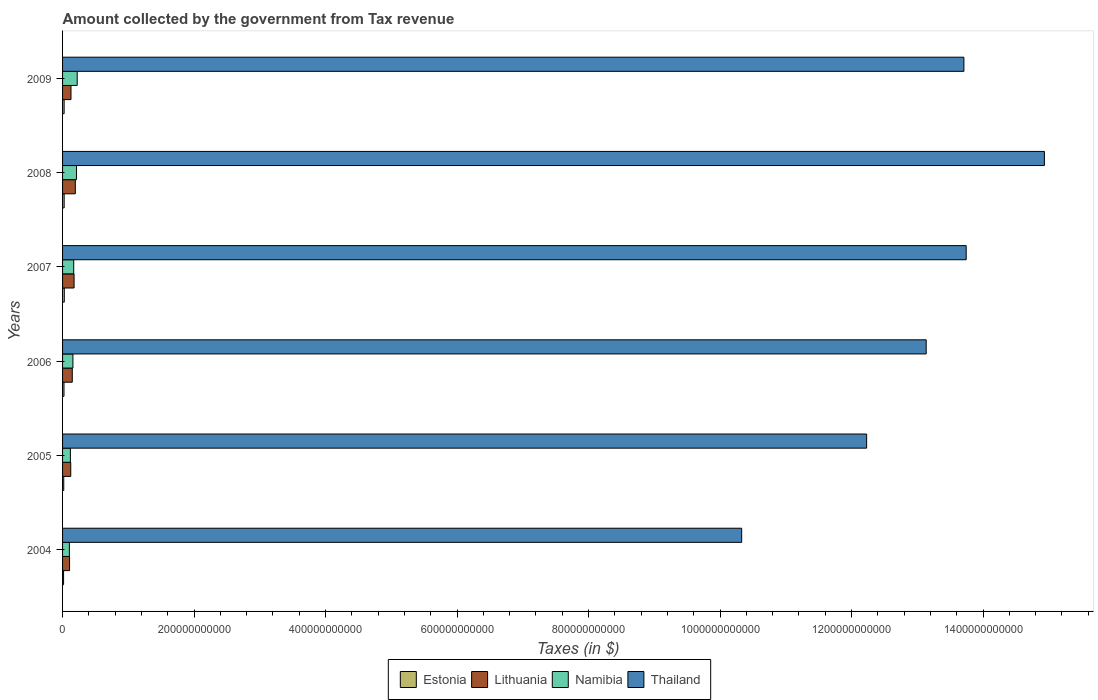How many groups of bars are there?
Offer a very short reply. 6. Are the number of bars per tick equal to the number of legend labels?
Offer a terse response. Yes. How many bars are there on the 5th tick from the top?
Make the answer very short. 4. How many bars are there on the 3rd tick from the bottom?
Provide a succinct answer. 4. What is the label of the 5th group of bars from the top?
Keep it short and to the point. 2005. In how many cases, is the number of bars for a given year not equal to the number of legend labels?
Keep it short and to the point. 0. What is the amount collected by the government from tax revenue in Estonia in 2007?
Ensure brevity in your answer.  2.63e+09. Across all years, what is the maximum amount collected by the government from tax revenue in Estonia?
Make the answer very short. 2.63e+09. Across all years, what is the minimum amount collected by the government from tax revenue in Thailand?
Ensure brevity in your answer.  1.03e+12. What is the total amount collected by the government from tax revenue in Estonia in the graph?
Ensure brevity in your answer.  1.30e+1. What is the difference between the amount collected by the government from tax revenue in Estonia in 2004 and that in 2008?
Offer a terse response. -8.84e+08. What is the difference between the amount collected by the government from tax revenue in Lithuania in 2008 and the amount collected by the government from tax revenue in Thailand in 2007?
Ensure brevity in your answer.  -1.36e+12. What is the average amount collected by the government from tax revenue in Thailand per year?
Your answer should be very brief. 1.30e+12. In the year 2004, what is the difference between the amount collected by the government from tax revenue in Thailand and amount collected by the government from tax revenue in Namibia?
Your response must be concise. 1.02e+12. What is the ratio of the amount collected by the government from tax revenue in Thailand in 2006 to that in 2008?
Provide a short and direct response. 0.88. What is the difference between the highest and the second highest amount collected by the government from tax revenue in Thailand?
Your answer should be very brief. 1.19e+11. What is the difference between the highest and the lowest amount collected by the government from tax revenue in Thailand?
Offer a terse response. 4.60e+11. Is the sum of the amount collected by the government from tax revenue in Lithuania in 2004 and 2008 greater than the maximum amount collected by the government from tax revenue in Thailand across all years?
Your answer should be compact. No. Is it the case that in every year, the sum of the amount collected by the government from tax revenue in Thailand and amount collected by the government from tax revenue in Lithuania is greater than the sum of amount collected by the government from tax revenue in Estonia and amount collected by the government from tax revenue in Namibia?
Offer a very short reply. Yes. What does the 3rd bar from the top in 2005 represents?
Offer a very short reply. Lithuania. What does the 4th bar from the bottom in 2007 represents?
Your answer should be very brief. Thailand. Is it the case that in every year, the sum of the amount collected by the government from tax revenue in Namibia and amount collected by the government from tax revenue in Lithuania is greater than the amount collected by the government from tax revenue in Estonia?
Provide a succinct answer. Yes. How many bars are there?
Make the answer very short. 24. Are all the bars in the graph horizontal?
Keep it short and to the point. Yes. How many years are there in the graph?
Your answer should be compact. 6. What is the difference between two consecutive major ticks on the X-axis?
Provide a short and direct response. 2.00e+11. Does the graph contain any zero values?
Keep it short and to the point. No. Does the graph contain grids?
Provide a succinct answer. No. How many legend labels are there?
Keep it short and to the point. 4. What is the title of the graph?
Ensure brevity in your answer.  Amount collected by the government from Tax revenue. Does "Kazakhstan" appear as one of the legend labels in the graph?
Your answer should be very brief. No. What is the label or title of the X-axis?
Make the answer very short. Taxes (in $). What is the label or title of the Y-axis?
Keep it short and to the point. Years. What is the Taxes (in $) of Estonia in 2004?
Make the answer very short. 1.55e+09. What is the Taxes (in $) of Lithuania in 2004?
Ensure brevity in your answer.  1.06e+1. What is the Taxes (in $) of Namibia in 2004?
Your answer should be very brief. 1.04e+1. What is the Taxes (in $) of Thailand in 2004?
Offer a terse response. 1.03e+12. What is the Taxes (in $) in Estonia in 2005?
Offer a terse response. 1.80e+09. What is the Taxes (in $) of Lithuania in 2005?
Keep it short and to the point. 1.24e+1. What is the Taxes (in $) of Namibia in 2005?
Provide a short and direct response. 1.19e+1. What is the Taxes (in $) of Thailand in 2005?
Your response must be concise. 1.22e+12. What is the Taxes (in $) of Estonia in 2006?
Provide a short and direct response. 2.17e+09. What is the Taxes (in $) of Lithuania in 2006?
Offer a terse response. 1.48e+1. What is the Taxes (in $) of Namibia in 2006?
Make the answer very short. 1.57e+1. What is the Taxes (in $) in Thailand in 2006?
Provide a short and direct response. 1.31e+12. What is the Taxes (in $) of Estonia in 2007?
Give a very brief answer. 2.63e+09. What is the Taxes (in $) in Lithuania in 2007?
Make the answer very short. 1.75e+1. What is the Taxes (in $) of Namibia in 2007?
Your answer should be very brief. 1.70e+1. What is the Taxes (in $) of Thailand in 2007?
Offer a terse response. 1.37e+12. What is the Taxes (in $) of Estonia in 2008?
Ensure brevity in your answer.  2.43e+09. What is the Taxes (in $) in Lithuania in 2008?
Offer a very short reply. 1.94e+1. What is the Taxes (in $) of Namibia in 2008?
Keep it short and to the point. 2.12e+1. What is the Taxes (in $) of Thailand in 2008?
Provide a succinct answer. 1.49e+12. What is the Taxes (in $) in Estonia in 2009?
Your answer should be compact. 2.38e+09. What is the Taxes (in $) of Lithuania in 2009?
Keep it short and to the point. 1.28e+1. What is the Taxes (in $) of Namibia in 2009?
Provide a succinct answer. 2.23e+1. What is the Taxes (in $) of Thailand in 2009?
Your answer should be compact. 1.37e+12. Across all years, what is the maximum Taxes (in $) of Estonia?
Give a very brief answer. 2.63e+09. Across all years, what is the maximum Taxes (in $) in Lithuania?
Give a very brief answer. 1.94e+1. Across all years, what is the maximum Taxes (in $) in Namibia?
Offer a terse response. 2.23e+1. Across all years, what is the maximum Taxes (in $) in Thailand?
Make the answer very short. 1.49e+12. Across all years, what is the minimum Taxes (in $) of Estonia?
Your answer should be compact. 1.55e+09. Across all years, what is the minimum Taxes (in $) of Lithuania?
Give a very brief answer. 1.06e+1. Across all years, what is the minimum Taxes (in $) in Namibia?
Provide a short and direct response. 1.04e+1. Across all years, what is the minimum Taxes (in $) of Thailand?
Your response must be concise. 1.03e+12. What is the total Taxes (in $) of Estonia in the graph?
Give a very brief answer. 1.30e+1. What is the total Taxes (in $) of Lithuania in the graph?
Keep it short and to the point. 8.75e+1. What is the total Taxes (in $) of Namibia in the graph?
Offer a terse response. 9.85e+1. What is the total Taxes (in $) in Thailand in the graph?
Your response must be concise. 7.81e+12. What is the difference between the Taxes (in $) in Estonia in 2004 and that in 2005?
Offer a very short reply. -2.50e+08. What is the difference between the Taxes (in $) in Lithuania in 2004 and that in 2005?
Keep it short and to the point. -1.80e+09. What is the difference between the Taxes (in $) in Namibia in 2004 and that in 2005?
Your answer should be very brief. -1.53e+09. What is the difference between the Taxes (in $) in Thailand in 2004 and that in 2005?
Offer a terse response. -1.90e+11. What is the difference between the Taxes (in $) in Estonia in 2004 and that in 2006?
Offer a terse response. -6.21e+08. What is the difference between the Taxes (in $) of Lithuania in 2004 and that in 2006?
Make the answer very short. -4.15e+09. What is the difference between the Taxes (in $) in Namibia in 2004 and that in 2006?
Provide a succinct answer. -5.38e+09. What is the difference between the Taxes (in $) of Thailand in 2004 and that in 2006?
Make the answer very short. -2.81e+11. What is the difference between the Taxes (in $) of Estonia in 2004 and that in 2007?
Offer a very short reply. -1.09e+09. What is the difference between the Taxes (in $) in Lithuania in 2004 and that in 2007?
Make the answer very short. -6.88e+09. What is the difference between the Taxes (in $) in Namibia in 2004 and that in 2007?
Keep it short and to the point. -6.60e+09. What is the difference between the Taxes (in $) of Thailand in 2004 and that in 2007?
Your answer should be very brief. -3.41e+11. What is the difference between the Taxes (in $) of Estonia in 2004 and that in 2008?
Your response must be concise. -8.84e+08. What is the difference between the Taxes (in $) in Lithuania in 2004 and that in 2008?
Provide a succinct answer. -8.75e+09. What is the difference between the Taxes (in $) in Namibia in 2004 and that in 2008?
Give a very brief answer. -1.09e+1. What is the difference between the Taxes (in $) of Thailand in 2004 and that in 2008?
Ensure brevity in your answer.  -4.60e+11. What is the difference between the Taxes (in $) in Estonia in 2004 and that in 2009?
Ensure brevity in your answer.  -8.34e+08. What is the difference between the Taxes (in $) in Lithuania in 2004 and that in 2009?
Provide a short and direct response. -2.16e+09. What is the difference between the Taxes (in $) of Namibia in 2004 and that in 2009?
Keep it short and to the point. -1.19e+1. What is the difference between the Taxes (in $) in Thailand in 2004 and that in 2009?
Provide a succinct answer. -3.38e+11. What is the difference between the Taxes (in $) in Estonia in 2005 and that in 2006?
Keep it short and to the point. -3.71e+08. What is the difference between the Taxes (in $) of Lithuania in 2005 and that in 2006?
Keep it short and to the point. -2.35e+09. What is the difference between the Taxes (in $) in Namibia in 2005 and that in 2006?
Provide a short and direct response. -3.85e+09. What is the difference between the Taxes (in $) of Thailand in 2005 and that in 2006?
Make the answer very short. -9.06e+1. What is the difference between the Taxes (in $) of Estonia in 2005 and that in 2007?
Provide a short and direct response. -8.36e+08. What is the difference between the Taxes (in $) in Lithuania in 2005 and that in 2007?
Provide a short and direct response. -5.07e+09. What is the difference between the Taxes (in $) of Namibia in 2005 and that in 2007?
Provide a short and direct response. -5.07e+09. What is the difference between the Taxes (in $) of Thailand in 2005 and that in 2007?
Keep it short and to the point. -1.51e+11. What is the difference between the Taxes (in $) of Estonia in 2005 and that in 2008?
Ensure brevity in your answer.  -6.34e+08. What is the difference between the Taxes (in $) in Lithuania in 2005 and that in 2008?
Offer a terse response. -6.94e+09. What is the difference between the Taxes (in $) in Namibia in 2005 and that in 2008?
Offer a terse response. -9.33e+09. What is the difference between the Taxes (in $) of Thailand in 2005 and that in 2008?
Ensure brevity in your answer.  -2.70e+11. What is the difference between the Taxes (in $) of Estonia in 2005 and that in 2009?
Provide a short and direct response. -5.85e+08. What is the difference between the Taxes (in $) in Lithuania in 2005 and that in 2009?
Provide a short and direct response. -3.57e+08. What is the difference between the Taxes (in $) in Namibia in 2005 and that in 2009?
Offer a terse response. -1.04e+1. What is the difference between the Taxes (in $) of Thailand in 2005 and that in 2009?
Offer a terse response. -1.48e+11. What is the difference between the Taxes (in $) of Estonia in 2006 and that in 2007?
Your answer should be very brief. -4.65e+08. What is the difference between the Taxes (in $) in Lithuania in 2006 and that in 2007?
Keep it short and to the point. -2.73e+09. What is the difference between the Taxes (in $) in Namibia in 2006 and that in 2007?
Your answer should be compact. -1.22e+09. What is the difference between the Taxes (in $) of Thailand in 2006 and that in 2007?
Provide a succinct answer. -6.08e+1. What is the difference between the Taxes (in $) in Estonia in 2006 and that in 2008?
Provide a succinct answer. -2.63e+08. What is the difference between the Taxes (in $) in Lithuania in 2006 and that in 2008?
Offer a very short reply. -4.60e+09. What is the difference between the Taxes (in $) of Namibia in 2006 and that in 2008?
Provide a short and direct response. -5.48e+09. What is the difference between the Taxes (in $) in Thailand in 2006 and that in 2008?
Give a very brief answer. -1.80e+11. What is the difference between the Taxes (in $) of Estonia in 2006 and that in 2009?
Make the answer very short. -2.13e+08. What is the difference between the Taxes (in $) of Lithuania in 2006 and that in 2009?
Offer a very short reply. 1.99e+09. What is the difference between the Taxes (in $) in Namibia in 2006 and that in 2009?
Ensure brevity in your answer.  -6.53e+09. What is the difference between the Taxes (in $) in Thailand in 2006 and that in 2009?
Keep it short and to the point. -5.74e+1. What is the difference between the Taxes (in $) of Estonia in 2007 and that in 2008?
Give a very brief answer. 2.02e+08. What is the difference between the Taxes (in $) in Lithuania in 2007 and that in 2008?
Keep it short and to the point. -1.87e+09. What is the difference between the Taxes (in $) of Namibia in 2007 and that in 2008?
Provide a short and direct response. -4.25e+09. What is the difference between the Taxes (in $) in Thailand in 2007 and that in 2008?
Make the answer very short. -1.19e+11. What is the difference between the Taxes (in $) in Estonia in 2007 and that in 2009?
Offer a very short reply. 2.51e+08. What is the difference between the Taxes (in $) of Lithuania in 2007 and that in 2009?
Offer a very short reply. 4.72e+09. What is the difference between the Taxes (in $) in Namibia in 2007 and that in 2009?
Give a very brief answer. -5.30e+09. What is the difference between the Taxes (in $) in Thailand in 2007 and that in 2009?
Keep it short and to the point. 3.46e+09. What is the difference between the Taxes (in $) in Estonia in 2008 and that in 2009?
Keep it short and to the point. 4.95e+07. What is the difference between the Taxes (in $) in Lithuania in 2008 and that in 2009?
Your answer should be very brief. 6.59e+09. What is the difference between the Taxes (in $) in Namibia in 2008 and that in 2009?
Ensure brevity in your answer.  -1.05e+09. What is the difference between the Taxes (in $) of Thailand in 2008 and that in 2009?
Offer a terse response. 1.22e+11. What is the difference between the Taxes (in $) in Estonia in 2004 and the Taxes (in $) in Lithuania in 2005?
Your answer should be very brief. -1.09e+1. What is the difference between the Taxes (in $) in Estonia in 2004 and the Taxes (in $) in Namibia in 2005?
Your answer should be very brief. -1.03e+1. What is the difference between the Taxes (in $) in Estonia in 2004 and the Taxes (in $) in Thailand in 2005?
Your answer should be compact. -1.22e+12. What is the difference between the Taxes (in $) of Lithuania in 2004 and the Taxes (in $) of Namibia in 2005?
Offer a terse response. -1.26e+09. What is the difference between the Taxes (in $) of Lithuania in 2004 and the Taxes (in $) of Thailand in 2005?
Give a very brief answer. -1.21e+12. What is the difference between the Taxes (in $) in Namibia in 2004 and the Taxes (in $) in Thailand in 2005?
Your answer should be compact. -1.21e+12. What is the difference between the Taxes (in $) of Estonia in 2004 and the Taxes (in $) of Lithuania in 2006?
Ensure brevity in your answer.  -1.32e+1. What is the difference between the Taxes (in $) of Estonia in 2004 and the Taxes (in $) of Namibia in 2006?
Your answer should be very brief. -1.42e+1. What is the difference between the Taxes (in $) in Estonia in 2004 and the Taxes (in $) in Thailand in 2006?
Keep it short and to the point. -1.31e+12. What is the difference between the Taxes (in $) of Lithuania in 2004 and the Taxes (in $) of Namibia in 2006?
Provide a short and direct response. -5.11e+09. What is the difference between the Taxes (in $) of Lithuania in 2004 and the Taxes (in $) of Thailand in 2006?
Make the answer very short. -1.30e+12. What is the difference between the Taxes (in $) in Namibia in 2004 and the Taxes (in $) in Thailand in 2006?
Make the answer very short. -1.30e+12. What is the difference between the Taxes (in $) of Estonia in 2004 and the Taxes (in $) of Lithuania in 2007?
Offer a terse response. -1.60e+1. What is the difference between the Taxes (in $) in Estonia in 2004 and the Taxes (in $) in Namibia in 2007?
Ensure brevity in your answer.  -1.54e+1. What is the difference between the Taxes (in $) of Estonia in 2004 and the Taxes (in $) of Thailand in 2007?
Offer a terse response. -1.37e+12. What is the difference between the Taxes (in $) in Lithuania in 2004 and the Taxes (in $) in Namibia in 2007?
Your answer should be compact. -6.33e+09. What is the difference between the Taxes (in $) of Lithuania in 2004 and the Taxes (in $) of Thailand in 2007?
Make the answer very short. -1.36e+12. What is the difference between the Taxes (in $) of Namibia in 2004 and the Taxes (in $) of Thailand in 2007?
Your answer should be very brief. -1.36e+12. What is the difference between the Taxes (in $) of Estonia in 2004 and the Taxes (in $) of Lithuania in 2008?
Offer a very short reply. -1.78e+1. What is the difference between the Taxes (in $) in Estonia in 2004 and the Taxes (in $) in Namibia in 2008?
Ensure brevity in your answer.  -1.97e+1. What is the difference between the Taxes (in $) in Estonia in 2004 and the Taxes (in $) in Thailand in 2008?
Your response must be concise. -1.49e+12. What is the difference between the Taxes (in $) in Lithuania in 2004 and the Taxes (in $) in Namibia in 2008?
Give a very brief answer. -1.06e+1. What is the difference between the Taxes (in $) in Lithuania in 2004 and the Taxes (in $) in Thailand in 2008?
Offer a terse response. -1.48e+12. What is the difference between the Taxes (in $) in Namibia in 2004 and the Taxes (in $) in Thailand in 2008?
Keep it short and to the point. -1.48e+12. What is the difference between the Taxes (in $) in Estonia in 2004 and the Taxes (in $) in Lithuania in 2009?
Keep it short and to the point. -1.12e+1. What is the difference between the Taxes (in $) in Estonia in 2004 and the Taxes (in $) in Namibia in 2009?
Offer a very short reply. -2.07e+1. What is the difference between the Taxes (in $) of Estonia in 2004 and the Taxes (in $) of Thailand in 2009?
Ensure brevity in your answer.  -1.37e+12. What is the difference between the Taxes (in $) of Lithuania in 2004 and the Taxes (in $) of Namibia in 2009?
Offer a terse response. -1.16e+1. What is the difference between the Taxes (in $) in Lithuania in 2004 and the Taxes (in $) in Thailand in 2009?
Your answer should be very brief. -1.36e+12. What is the difference between the Taxes (in $) of Namibia in 2004 and the Taxes (in $) of Thailand in 2009?
Offer a terse response. -1.36e+12. What is the difference between the Taxes (in $) of Estonia in 2005 and the Taxes (in $) of Lithuania in 2006?
Keep it short and to the point. -1.30e+1. What is the difference between the Taxes (in $) of Estonia in 2005 and the Taxes (in $) of Namibia in 2006?
Offer a very short reply. -1.40e+1. What is the difference between the Taxes (in $) of Estonia in 2005 and the Taxes (in $) of Thailand in 2006?
Your response must be concise. -1.31e+12. What is the difference between the Taxes (in $) in Lithuania in 2005 and the Taxes (in $) in Namibia in 2006?
Your answer should be very brief. -3.31e+09. What is the difference between the Taxes (in $) of Lithuania in 2005 and the Taxes (in $) of Thailand in 2006?
Your answer should be very brief. -1.30e+12. What is the difference between the Taxes (in $) in Namibia in 2005 and the Taxes (in $) in Thailand in 2006?
Make the answer very short. -1.30e+12. What is the difference between the Taxes (in $) in Estonia in 2005 and the Taxes (in $) in Lithuania in 2007?
Make the answer very short. -1.57e+1. What is the difference between the Taxes (in $) in Estonia in 2005 and the Taxes (in $) in Namibia in 2007?
Your answer should be compact. -1.52e+1. What is the difference between the Taxes (in $) of Estonia in 2005 and the Taxes (in $) of Thailand in 2007?
Your answer should be very brief. -1.37e+12. What is the difference between the Taxes (in $) of Lithuania in 2005 and the Taxes (in $) of Namibia in 2007?
Your answer should be very brief. -4.53e+09. What is the difference between the Taxes (in $) in Lithuania in 2005 and the Taxes (in $) in Thailand in 2007?
Your response must be concise. -1.36e+12. What is the difference between the Taxes (in $) of Namibia in 2005 and the Taxes (in $) of Thailand in 2007?
Your answer should be very brief. -1.36e+12. What is the difference between the Taxes (in $) of Estonia in 2005 and the Taxes (in $) of Lithuania in 2008?
Your answer should be very brief. -1.76e+1. What is the difference between the Taxes (in $) in Estonia in 2005 and the Taxes (in $) in Namibia in 2008?
Your answer should be very brief. -1.94e+1. What is the difference between the Taxes (in $) of Estonia in 2005 and the Taxes (in $) of Thailand in 2008?
Keep it short and to the point. -1.49e+12. What is the difference between the Taxes (in $) of Lithuania in 2005 and the Taxes (in $) of Namibia in 2008?
Your answer should be compact. -8.79e+09. What is the difference between the Taxes (in $) in Lithuania in 2005 and the Taxes (in $) in Thailand in 2008?
Provide a succinct answer. -1.48e+12. What is the difference between the Taxes (in $) in Namibia in 2005 and the Taxes (in $) in Thailand in 2008?
Your response must be concise. -1.48e+12. What is the difference between the Taxes (in $) of Estonia in 2005 and the Taxes (in $) of Lithuania in 2009?
Keep it short and to the point. -1.10e+1. What is the difference between the Taxes (in $) in Estonia in 2005 and the Taxes (in $) in Namibia in 2009?
Your answer should be very brief. -2.05e+1. What is the difference between the Taxes (in $) in Estonia in 2005 and the Taxes (in $) in Thailand in 2009?
Your answer should be very brief. -1.37e+12. What is the difference between the Taxes (in $) of Lithuania in 2005 and the Taxes (in $) of Namibia in 2009?
Ensure brevity in your answer.  -9.84e+09. What is the difference between the Taxes (in $) in Lithuania in 2005 and the Taxes (in $) in Thailand in 2009?
Your response must be concise. -1.36e+12. What is the difference between the Taxes (in $) in Namibia in 2005 and the Taxes (in $) in Thailand in 2009?
Offer a terse response. -1.36e+12. What is the difference between the Taxes (in $) of Estonia in 2006 and the Taxes (in $) of Lithuania in 2007?
Make the answer very short. -1.53e+1. What is the difference between the Taxes (in $) of Estonia in 2006 and the Taxes (in $) of Namibia in 2007?
Offer a terse response. -1.48e+1. What is the difference between the Taxes (in $) of Estonia in 2006 and the Taxes (in $) of Thailand in 2007?
Offer a terse response. -1.37e+12. What is the difference between the Taxes (in $) in Lithuania in 2006 and the Taxes (in $) in Namibia in 2007?
Provide a short and direct response. -2.18e+09. What is the difference between the Taxes (in $) in Lithuania in 2006 and the Taxes (in $) in Thailand in 2007?
Offer a very short reply. -1.36e+12. What is the difference between the Taxes (in $) in Namibia in 2006 and the Taxes (in $) in Thailand in 2007?
Your answer should be compact. -1.36e+12. What is the difference between the Taxes (in $) of Estonia in 2006 and the Taxes (in $) of Lithuania in 2008?
Offer a very short reply. -1.72e+1. What is the difference between the Taxes (in $) of Estonia in 2006 and the Taxes (in $) of Namibia in 2008?
Ensure brevity in your answer.  -1.91e+1. What is the difference between the Taxes (in $) of Estonia in 2006 and the Taxes (in $) of Thailand in 2008?
Keep it short and to the point. -1.49e+12. What is the difference between the Taxes (in $) of Lithuania in 2006 and the Taxes (in $) of Namibia in 2008?
Make the answer very short. -6.44e+09. What is the difference between the Taxes (in $) in Lithuania in 2006 and the Taxes (in $) in Thailand in 2008?
Keep it short and to the point. -1.48e+12. What is the difference between the Taxes (in $) of Namibia in 2006 and the Taxes (in $) of Thailand in 2008?
Provide a short and direct response. -1.48e+12. What is the difference between the Taxes (in $) in Estonia in 2006 and the Taxes (in $) in Lithuania in 2009?
Provide a succinct answer. -1.06e+1. What is the difference between the Taxes (in $) in Estonia in 2006 and the Taxes (in $) in Namibia in 2009?
Offer a very short reply. -2.01e+1. What is the difference between the Taxes (in $) in Estonia in 2006 and the Taxes (in $) in Thailand in 2009?
Give a very brief answer. -1.37e+12. What is the difference between the Taxes (in $) of Lithuania in 2006 and the Taxes (in $) of Namibia in 2009?
Your answer should be very brief. -7.49e+09. What is the difference between the Taxes (in $) in Lithuania in 2006 and the Taxes (in $) in Thailand in 2009?
Ensure brevity in your answer.  -1.36e+12. What is the difference between the Taxes (in $) of Namibia in 2006 and the Taxes (in $) of Thailand in 2009?
Provide a succinct answer. -1.36e+12. What is the difference between the Taxes (in $) of Estonia in 2007 and the Taxes (in $) of Lithuania in 2008?
Offer a terse response. -1.67e+1. What is the difference between the Taxes (in $) in Estonia in 2007 and the Taxes (in $) in Namibia in 2008?
Make the answer very short. -1.86e+1. What is the difference between the Taxes (in $) of Estonia in 2007 and the Taxes (in $) of Thailand in 2008?
Provide a succinct answer. -1.49e+12. What is the difference between the Taxes (in $) of Lithuania in 2007 and the Taxes (in $) of Namibia in 2008?
Keep it short and to the point. -3.71e+09. What is the difference between the Taxes (in $) in Lithuania in 2007 and the Taxes (in $) in Thailand in 2008?
Ensure brevity in your answer.  -1.48e+12. What is the difference between the Taxes (in $) of Namibia in 2007 and the Taxes (in $) of Thailand in 2008?
Offer a very short reply. -1.48e+12. What is the difference between the Taxes (in $) in Estonia in 2007 and the Taxes (in $) in Lithuania in 2009?
Provide a succinct answer. -1.02e+1. What is the difference between the Taxes (in $) in Estonia in 2007 and the Taxes (in $) in Namibia in 2009?
Provide a succinct answer. -1.96e+1. What is the difference between the Taxes (in $) of Estonia in 2007 and the Taxes (in $) of Thailand in 2009?
Keep it short and to the point. -1.37e+12. What is the difference between the Taxes (in $) of Lithuania in 2007 and the Taxes (in $) of Namibia in 2009?
Ensure brevity in your answer.  -4.76e+09. What is the difference between the Taxes (in $) in Lithuania in 2007 and the Taxes (in $) in Thailand in 2009?
Provide a short and direct response. -1.35e+12. What is the difference between the Taxes (in $) in Namibia in 2007 and the Taxes (in $) in Thailand in 2009?
Offer a very short reply. -1.35e+12. What is the difference between the Taxes (in $) of Estonia in 2008 and the Taxes (in $) of Lithuania in 2009?
Provide a succinct answer. -1.04e+1. What is the difference between the Taxes (in $) of Estonia in 2008 and the Taxes (in $) of Namibia in 2009?
Your answer should be very brief. -1.98e+1. What is the difference between the Taxes (in $) of Estonia in 2008 and the Taxes (in $) of Thailand in 2009?
Make the answer very short. -1.37e+12. What is the difference between the Taxes (in $) of Lithuania in 2008 and the Taxes (in $) of Namibia in 2009?
Make the answer very short. -2.89e+09. What is the difference between the Taxes (in $) of Lithuania in 2008 and the Taxes (in $) of Thailand in 2009?
Offer a very short reply. -1.35e+12. What is the difference between the Taxes (in $) of Namibia in 2008 and the Taxes (in $) of Thailand in 2009?
Offer a terse response. -1.35e+12. What is the average Taxes (in $) of Estonia per year?
Your answer should be very brief. 2.16e+09. What is the average Taxes (in $) of Lithuania per year?
Make the answer very short. 1.46e+1. What is the average Taxes (in $) in Namibia per year?
Provide a succinct answer. 1.64e+1. What is the average Taxes (in $) of Thailand per year?
Make the answer very short. 1.30e+12. In the year 2004, what is the difference between the Taxes (in $) of Estonia and Taxes (in $) of Lithuania?
Your answer should be very brief. -9.09e+09. In the year 2004, what is the difference between the Taxes (in $) in Estonia and Taxes (in $) in Namibia?
Offer a very short reply. -8.82e+09. In the year 2004, what is the difference between the Taxes (in $) in Estonia and Taxes (in $) in Thailand?
Give a very brief answer. -1.03e+12. In the year 2004, what is the difference between the Taxes (in $) in Lithuania and Taxes (in $) in Namibia?
Keep it short and to the point. 2.69e+08. In the year 2004, what is the difference between the Taxes (in $) of Lithuania and Taxes (in $) of Thailand?
Keep it short and to the point. -1.02e+12. In the year 2004, what is the difference between the Taxes (in $) of Namibia and Taxes (in $) of Thailand?
Provide a short and direct response. -1.02e+12. In the year 2005, what is the difference between the Taxes (in $) of Estonia and Taxes (in $) of Lithuania?
Your response must be concise. -1.06e+1. In the year 2005, what is the difference between the Taxes (in $) in Estonia and Taxes (in $) in Namibia?
Your response must be concise. -1.01e+1. In the year 2005, what is the difference between the Taxes (in $) in Estonia and Taxes (in $) in Thailand?
Your answer should be compact. -1.22e+12. In the year 2005, what is the difference between the Taxes (in $) in Lithuania and Taxes (in $) in Namibia?
Your answer should be compact. 5.42e+08. In the year 2005, what is the difference between the Taxes (in $) of Lithuania and Taxes (in $) of Thailand?
Ensure brevity in your answer.  -1.21e+12. In the year 2005, what is the difference between the Taxes (in $) in Namibia and Taxes (in $) in Thailand?
Offer a very short reply. -1.21e+12. In the year 2006, what is the difference between the Taxes (in $) of Estonia and Taxes (in $) of Lithuania?
Offer a very short reply. -1.26e+1. In the year 2006, what is the difference between the Taxes (in $) of Estonia and Taxes (in $) of Namibia?
Make the answer very short. -1.36e+1. In the year 2006, what is the difference between the Taxes (in $) of Estonia and Taxes (in $) of Thailand?
Offer a very short reply. -1.31e+12. In the year 2006, what is the difference between the Taxes (in $) of Lithuania and Taxes (in $) of Namibia?
Provide a short and direct response. -9.62e+08. In the year 2006, what is the difference between the Taxes (in $) of Lithuania and Taxes (in $) of Thailand?
Provide a succinct answer. -1.30e+12. In the year 2006, what is the difference between the Taxes (in $) in Namibia and Taxes (in $) in Thailand?
Give a very brief answer. -1.30e+12. In the year 2007, what is the difference between the Taxes (in $) of Estonia and Taxes (in $) of Lithuania?
Provide a succinct answer. -1.49e+1. In the year 2007, what is the difference between the Taxes (in $) in Estonia and Taxes (in $) in Namibia?
Provide a succinct answer. -1.43e+1. In the year 2007, what is the difference between the Taxes (in $) of Estonia and Taxes (in $) of Thailand?
Provide a succinct answer. -1.37e+12. In the year 2007, what is the difference between the Taxes (in $) of Lithuania and Taxes (in $) of Namibia?
Your answer should be compact. 5.42e+08. In the year 2007, what is the difference between the Taxes (in $) in Lithuania and Taxes (in $) in Thailand?
Your response must be concise. -1.36e+12. In the year 2007, what is the difference between the Taxes (in $) of Namibia and Taxes (in $) of Thailand?
Offer a very short reply. -1.36e+12. In the year 2008, what is the difference between the Taxes (in $) in Estonia and Taxes (in $) in Lithuania?
Give a very brief answer. -1.70e+1. In the year 2008, what is the difference between the Taxes (in $) of Estonia and Taxes (in $) of Namibia?
Provide a succinct answer. -1.88e+1. In the year 2008, what is the difference between the Taxes (in $) of Estonia and Taxes (in $) of Thailand?
Provide a succinct answer. -1.49e+12. In the year 2008, what is the difference between the Taxes (in $) in Lithuania and Taxes (in $) in Namibia?
Provide a succinct answer. -1.84e+09. In the year 2008, what is the difference between the Taxes (in $) of Lithuania and Taxes (in $) of Thailand?
Provide a short and direct response. -1.47e+12. In the year 2008, what is the difference between the Taxes (in $) of Namibia and Taxes (in $) of Thailand?
Offer a very short reply. -1.47e+12. In the year 2009, what is the difference between the Taxes (in $) in Estonia and Taxes (in $) in Lithuania?
Keep it short and to the point. -1.04e+1. In the year 2009, what is the difference between the Taxes (in $) in Estonia and Taxes (in $) in Namibia?
Offer a very short reply. -1.99e+1. In the year 2009, what is the difference between the Taxes (in $) in Estonia and Taxes (in $) in Thailand?
Your response must be concise. -1.37e+12. In the year 2009, what is the difference between the Taxes (in $) in Lithuania and Taxes (in $) in Namibia?
Offer a very short reply. -9.48e+09. In the year 2009, what is the difference between the Taxes (in $) in Lithuania and Taxes (in $) in Thailand?
Your response must be concise. -1.36e+12. In the year 2009, what is the difference between the Taxes (in $) in Namibia and Taxes (in $) in Thailand?
Give a very brief answer. -1.35e+12. What is the ratio of the Taxes (in $) in Estonia in 2004 to that in 2005?
Your response must be concise. 0.86. What is the ratio of the Taxes (in $) of Lithuania in 2004 to that in 2005?
Ensure brevity in your answer.  0.86. What is the ratio of the Taxes (in $) in Namibia in 2004 to that in 2005?
Your response must be concise. 0.87. What is the ratio of the Taxes (in $) in Thailand in 2004 to that in 2005?
Make the answer very short. 0.84. What is the ratio of the Taxes (in $) of Estonia in 2004 to that in 2006?
Give a very brief answer. 0.71. What is the ratio of the Taxes (in $) of Lithuania in 2004 to that in 2006?
Your answer should be compact. 0.72. What is the ratio of the Taxes (in $) of Namibia in 2004 to that in 2006?
Offer a terse response. 0.66. What is the ratio of the Taxes (in $) in Thailand in 2004 to that in 2006?
Ensure brevity in your answer.  0.79. What is the ratio of the Taxes (in $) of Estonia in 2004 to that in 2007?
Keep it short and to the point. 0.59. What is the ratio of the Taxes (in $) of Lithuania in 2004 to that in 2007?
Your answer should be very brief. 0.61. What is the ratio of the Taxes (in $) in Namibia in 2004 to that in 2007?
Make the answer very short. 0.61. What is the ratio of the Taxes (in $) of Thailand in 2004 to that in 2007?
Offer a terse response. 0.75. What is the ratio of the Taxes (in $) of Estonia in 2004 to that in 2008?
Give a very brief answer. 0.64. What is the ratio of the Taxes (in $) of Lithuania in 2004 to that in 2008?
Offer a terse response. 0.55. What is the ratio of the Taxes (in $) of Namibia in 2004 to that in 2008?
Keep it short and to the point. 0.49. What is the ratio of the Taxes (in $) in Thailand in 2004 to that in 2008?
Your response must be concise. 0.69. What is the ratio of the Taxes (in $) of Estonia in 2004 to that in 2009?
Your response must be concise. 0.65. What is the ratio of the Taxes (in $) of Lithuania in 2004 to that in 2009?
Keep it short and to the point. 0.83. What is the ratio of the Taxes (in $) of Namibia in 2004 to that in 2009?
Keep it short and to the point. 0.47. What is the ratio of the Taxes (in $) in Thailand in 2004 to that in 2009?
Provide a short and direct response. 0.75. What is the ratio of the Taxes (in $) of Estonia in 2005 to that in 2006?
Your answer should be compact. 0.83. What is the ratio of the Taxes (in $) in Lithuania in 2005 to that in 2006?
Provide a short and direct response. 0.84. What is the ratio of the Taxes (in $) of Namibia in 2005 to that in 2006?
Provide a short and direct response. 0.76. What is the ratio of the Taxes (in $) in Estonia in 2005 to that in 2007?
Your answer should be very brief. 0.68. What is the ratio of the Taxes (in $) of Lithuania in 2005 to that in 2007?
Offer a terse response. 0.71. What is the ratio of the Taxes (in $) in Namibia in 2005 to that in 2007?
Provide a succinct answer. 0.7. What is the ratio of the Taxes (in $) in Thailand in 2005 to that in 2007?
Keep it short and to the point. 0.89. What is the ratio of the Taxes (in $) of Estonia in 2005 to that in 2008?
Give a very brief answer. 0.74. What is the ratio of the Taxes (in $) of Lithuania in 2005 to that in 2008?
Ensure brevity in your answer.  0.64. What is the ratio of the Taxes (in $) of Namibia in 2005 to that in 2008?
Provide a short and direct response. 0.56. What is the ratio of the Taxes (in $) of Thailand in 2005 to that in 2008?
Offer a very short reply. 0.82. What is the ratio of the Taxes (in $) of Estonia in 2005 to that in 2009?
Keep it short and to the point. 0.75. What is the ratio of the Taxes (in $) in Lithuania in 2005 to that in 2009?
Your answer should be compact. 0.97. What is the ratio of the Taxes (in $) of Namibia in 2005 to that in 2009?
Ensure brevity in your answer.  0.53. What is the ratio of the Taxes (in $) in Thailand in 2005 to that in 2009?
Offer a terse response. 0.89. What is the ratio of the Taxes (in $) of Estonia in 2006 to that in 2007?
Your response must be concise. 0.82. What is the ratio of the Taxes (in $) of Lithuania in 2006 to that in 2007?
Offer a very short reply. 0.84. What is the ratio of the Taxes (in $) in Namibia in 2006 to that in 2007?
Your answer should be very brief. 0.93. What is the ratio of the Taxes (in $) of Thailand in 2006 to that in 2007?
Provide a succinct answer. 0.96. What is the ratio of the Taxes (in $) in Estonia in 2006 to that in 2008?
Your response must be concise. 0.89. What is the ratio of the Taxes (in $) of Lithuania in 2006 to that in 2008?
Your answer should be compact. 0.76. What is the ratio of the Taxes (in $) of Namibia in 2006 to that in 2008?
Keep it short and to the point. 0.74. What is the ratio of the Taxes (in $) of Thailand in 2006 to that in 2008?
Offer a terse response. 0.88. What is the ratio of the Taxes (in $) in Estonia in 2006 to that in 2009?
Keep it short and to the point. 0.91. What is the ratio of the Taxes (in $) of Lithuania in 2006 to that in 2009?
Keep it short and to the point. 1.16. What is the ratio of the Taxes (in $) of Namibia in 2006 to that in 2009?
Provide a short and direct response. 0.71. What is the ratio of the Taxes (in $) of Thailand in 2006 to that in 2009?
Give a very brief answer. 0.96. What is the ratio of the Taxes (in $) of Estonia in 2007 to that in 2008?
Offer a terse response. 1.08. What is the ratio of the Taxes (in $) of Lithuania in 2007 to that in 2008?
Offer a very short reply. 0.9. What is the ratio of the Taxes (in $) in Namibia in 2007 to that in 2008?
Provide a short and direct response. 0.8. What is the ratio of the Taxes (in $) of Thailand in 2007 to that in 2008?
Your response must be concise. 0.92. What is the ratio of the Taxes (in $) in Estonia in 2007 to that in 2009?
Provide a succinct answer. 1.11. What is the ratio of the Taxes (in $) in Lithuania in 2007 to that in 2009?
Ensure brevity in your answer.  1.37. What is the ratio of the Taxes (in $) of Namibia in 2007 to that in 2009?
Provide a succinct answer. 0.76. What is the ratio of the Taxes (in $) of Thailand in 2007 to that in 2009?
Provide a short and direct response. 1. What is the ratio of the Taxes (in $) in Estonia in 2008 to that in 2009?
Provide a short and direct response. 1.02. What is the ratio of the Taxes (in $) in Lithuania in 2008 to that in 2009?
Give a very brief answer. 1.51. What is the ratio of the Taxes (in $) of Namibia in 2008 to that in 2009?
Offer a terse response. 0.95. What is the ratio of the Taxes (in $) in Thailand in 2008 to that in 2009?
Keep it short and to the point. 1.09. What is the difference between the highest and the second highest Taxes (in $) of Estonia?
Keep it short and to the point. 2.02e+08. What is the difference between the highest and the second highest Taxes (in $) of Lithuania?
Your response must be concise. 1.87e+09. What is the difference between the highest and the second highest Taxes (in $) in Namibia?
Your answer should be compact. 1.05e+09. What is the difference between the highest and the second highest Taxes (in $) in Thailand?
Offer a very short reply. 1.19e+11. What is the difference between the highest and the lowest Taxes (in $) in Estonia?
Your answer should be compact. 1.09e+09. What is the difference between the highest and the lowest Taxes (in $) of Lithuania?
Offer a very short reply. 8.75e+09. What is the difference between the highest and the lowest Taxes (in $) of Namibia?
Your response must be concise. 1.19e+1. What is the difference between the highest and the lowest Taxes (in $) in Thailand?
Make the answer very short. 4.60e+11. 